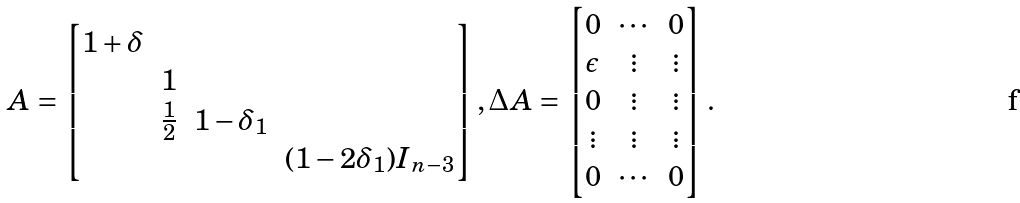<formula> <loc_0><loc_0><loc_500><loc_500>A = \left [ \begin{matrix} 1 + \delta & \ & \ & \ \\ \ & 1 & \ & \ \\ \ & \frac { 1 } { 2 } & 1 - \delta _ { 1 } & \ \\ \ & \ & \ & ( 1 - 2 \delta _ { 1 } ) I _ { n - 3 } \end{matrix} \right ] , \Delta A = \left [ \begin{matrix} 0 & \cdots & 0 \\ \epsilon & \vdots & \vdots \\ 0 & \vdots & \vdots \\ \vdots & \vdots & \vdots \\ 0 & \cdots & 0 \end{matrix} \right ] .</formula> 